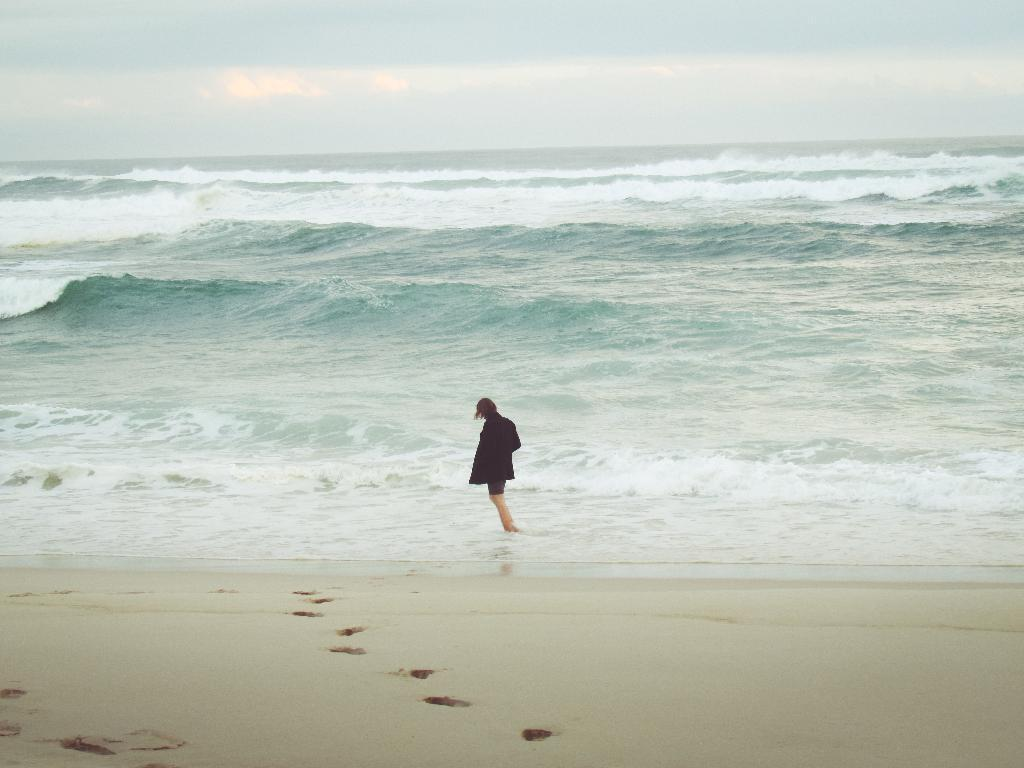What is the person in the image doing? The person is standing in the water in the middle of the image. What can be seen in the distance behind the person? There is an ocean in the background of the image. What else is visible in the background of the image? The sky is visible in the background of the image. What type of spoon is the person using to stir the water in the image? There is no spoon present in the image, and the person is not stirring the water. 